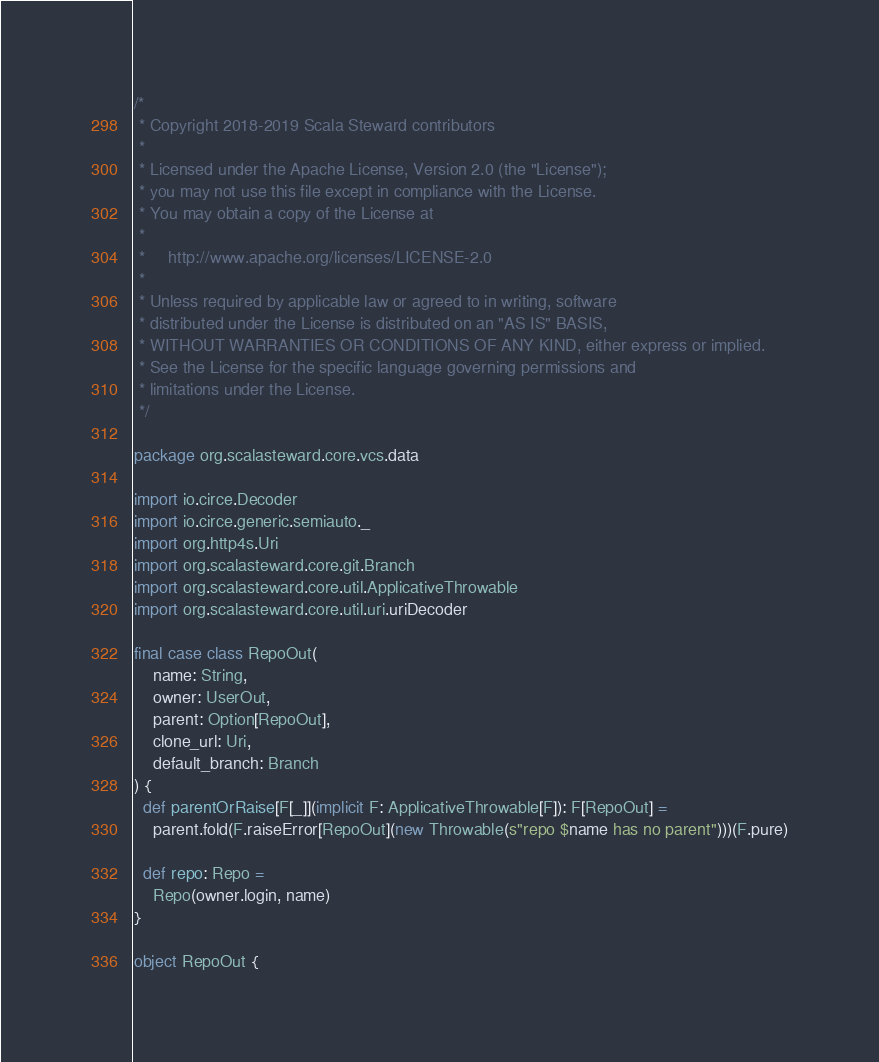Convert code to text. <code><loc_0><loc_0><loc_500><loc_500><_Scala_>/*
 * Copyright 2018-2019 Scala Steward contributors
 *
 * Licensed under the Apache License, Version 2.0 (the "License");
 * you may not use this file except in compliance with the License.
 * You may obtain a copy of the License at
 *
 *     http://www.apache.org/licenses/LICENSE-2.0
 *
 * Unless required by applicable law or agreed to in writing, software
 * distributed under the License is distributed on an "AS IS" BASIS,
 * WITHOUT WARRANTIES OR CONDITIONS OF ANY KIND, either express or implied.
 * See the License for the specific language governing permissions and
 * limitations under the License.
 */

package org.scalasteward.core.vcs.data

import io.circe.Decoder
import io.circe.generic.semiauto._
import org.http4s.Uri
import org.scalasteward.core.git.Branch
import org.scalasteward.core.util.ApplicativeThrowable
import org.scalasteward.core.util.uri.uriDecoder

final case class RepoOut(
    name: String,
    owner: UserOut,
    parent: Option[RepoOut],
    clone_url: Uri,
    default_branch: Branch
) {
  def parentOrRaise[F[_]](implicit F: ApplicativeThrowable[F]): F[RepoOut] =
    parent.fold(F.raiseError[RepoOut](new Throwable(s"repo $name has no parent")))(F.pure)

  def repo: Repo =
    Repo(owner.login, name)
}

object RepoOut {</code> 